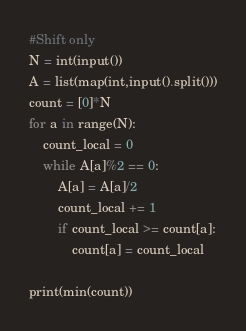<code> <loc_0><loc_0><loc_500><loc_500><_Python_>#Shift only
N = int(input())
A = list(map(int,input().split()))
count = [0]*N
for a in range(N):
    count_local = 0
    while A[a]%2 == 0:
        A[a] = A[a]/2
        count_local += 1
        if count_local >= count[a]:
            count[a] = count_local

print(min(count))</code> 